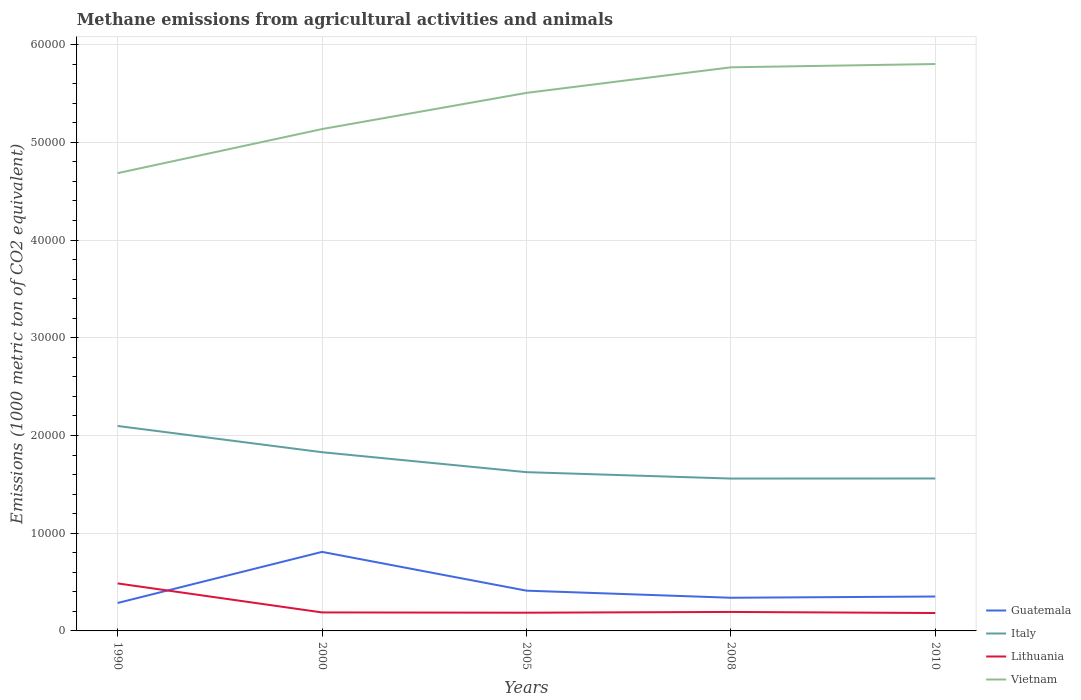Does the line corresponding to Italy intersect with the line corresponding to Guatemala?
Offer a very short reply. No. Across all years, what is the maximum amount of methane emitted in Guatemala?
Make the answer very short. 2860.2. What is the total amount of methane emitted in Lithuania in the graph?
Your answer should be compact. 2997.3. What is the difference between the highest and the second highest amount of methane emitted in Vietnam?
Your response must be concise. 1.12e+04. What is the difference between the highest and the lowest amount of methane emitted in Vietnam?
Make the answer very short. 3. Is the amount of methane emitted in Lithuania strictly greater than the amount of methane emitted in Guatemala over the years?
Your response must be concise. No. Are the values on the major ticks of Y-axis written in scientific E-notation?
Provide a short and direct response. No. Does the graph contain grids?
Keep it short and to the point. Yes. Where does the legend appear in the graph?
Offer a very short reply. Bottom right. What is the title of the graph?
Make the answer very short. Methane emissions from agricultural activities and animals. What is the label or title of the Y-axis?
Your response must be concise. Emissions (1000 metric ton of CO2 equivalent). What is the Emissions (1000 metric ton of CO2 equivalent) in Guatemala in 1990?
Your answer should be very brief. 2860.2. What is the Emissions (1000 metric ton of CO2 equivalent) in Italy in 1990?
Your response must be concise. 2.10e+04. What is the Emissions (1000 metric ton of CO2 equivalent) in Lithuania in 1990?
Keep it short and to the point. 4861.3. What is the Emissions (1000 metric ton of CO2 equivalent) in Vietnam in 1990?
Make the answer very short. 4.68e+04. What is the Emissions (1000 metric ton of CO2 equivalent) in Guatemala in 2000?
Offer a terse response. 8089.2. What is the Emissions (1000 metric ton of CO2 equivalent) of Italy in 2000?
Your answer should be compact. 1.83e+04. What is the Emissions (1000 metric ton of CO2 equivalent) in Lithuania in 2000?
Give a very brief answer. 1892.9. What is the Emissions (1000 metric ton of CO2 equivalent) of Vietnam in 2000?
Offer a very short reply. 5.14e+04. What is the Emissions (1000 metric ton of CO2 equivalent) in Guatemala in 2005?
Your response must be concise. 4120.8. What is the Emissions (1000 metric ton of CO2 equivalent) in Italy in 2005?
Offer a terse response. 1.62e+04. What is the Emissions (1000 metric ton of CO2 equivalent) in Lithuania in 2005?
Provide a short and direct response. 1864. What is the Emissions (1000 metric ton of CO2 equivalent) of Vietnam in 2005?
Make the answer very short. 5.51e+04. What is the Emissions (1000 metric ton of CO2 equivalent) of Guatemala in 2008?
Ensure brevity in your answer.  3394.9. What is the Emissions (1000 metric ton of CO2 equivalent) in Italy in 2008?
Offer a very short reply. 1.56e+04. What is the Emissions (1000 metric ton of CO2 equivalent) in Lithuania in 2008?
Give a very brief answer. 1942.5. What is the Emissions (1000 metric ton of CO2 equivalent) in Vietnam in 2008?
Your response must be concise. 5.77e+04. What is the Emissions (1000 metric ton of CO2 equivalent) in Guatemala in 2010?
Offer a terse response. 3521.2. What is the Emissions (1000 metric ton of CO2 equivalent) in Italy in 2010?
Ensure brevity in your answer.  1.56e+04. What is the Emissions (1000 metric ton of CO2 equivalent) in Lithuania in 2010?
Your answer should be compact. 1832.4. What is the Emissions (1000 metric ton of CO2 equivalent) of Vietnam in 2010?
Make the answer very short. 5.80e+04. Across all years, what is the maximum Emissions (1000 metric ton of CO2 equivalent) in Guatemala?
Your answer should be compact. 8089.2. Across all years, what is the maximum Emissions (1000 metric ton of CO2 equivalent) of Italy?
Provide a short and direct response. 2.10e+04. Across all years, what is the maximum Emissions (1000 metric ton of CO2 equivalent) in Lithuania?
Offer a very short reply. 4861.3. Across all years, what is the maximum Emissions (1000 metric ton of CO2 equivalent) in Vietnam?
Your answer should be compact. 5.80e+04. Across all years, what is the minimum Emissions (1000 metric ton of CO2 equivalent) of Guatemala?
Provide a short and direct response. 2860.2. Across all years, what is the minimum Emissions (1000 metric ton of CO2 equivalent) of Italy?
Provide a short and direct response. 1.56e+04. Across all years, what is the minimum Emissions (1000 metric ton of CO2 equivalent) in Lithuania?
Offer a terse response. 1832.4. Across all years, what is the minimum Emissions (1000 metric ton of CO2 equivalent) in Vietnam?
Your response must be concise. 4.68e+04. What is the total Emissions (1000 metric ton of CO2 equivalent) in Guatemala in the graph?
Your response must be concise. 2.20e+04. What is the total Emissions (1000 metric ton of CO2 equivalent) of Italy in the graph?
Offer a terse response. 8.67e+04. What is the total Emissions (1000 metric ton of CO2 equivalent) of Lithuania in the graph?
Offer a very short reply. 1.24e+04. What is the total Emissions (1000 metric ton of CO2 equivalent) of Vietnam in the graph?
Ensure brevity in your answer.  2.69e+05. What is the difference between the Emissions (1000 metric ton of CO2 equivalent) of Guatemala in 1990 and that in 2000?
Keep it short and to the point. -5229. What is the difference between the Emissions (1000 metric ton of CO2 equivalent) of Italy in 1990 and that in 2000?
Your answer should be very brief. 2687.3. What is the difference between the Emissions (1000 metric ton of CO2 equivalent) in Lithuania in 1990 and that in 2000?
Offer a very short reply. 2968.4. What is the difference between the Emissions (1000 metric ton of CO2 equivalent) of Vietnam in 1990 and that in 2000?
Your response must be concise. -4511. What is the difference between the Emissions (1000 metric ton of CO2 equivalent) in Guatemala in 1990 and that in 2005?
Offer a terse response. -1260.6. What is the difference between the Emissions (1000 metric ton of CO2 equivalent) of Italy in 1990 and that in 2005?
Keep it short and to the point. 4727.8. What is the difference between the Emissions (1000 metric ton of CO2 equivalent) in Lithuania in 1990 and that in 2005?
Keep it short and to the point. 2997.3. What is the difference between the Emissions (1000 metric ton of CO2 equivalent) of Vietnam in 1990 and that in 2005?
Make the answer very short. -8213.9. What is the difference between the Emissions (1000 metric ton of CO2 equivalent) of Guatemala in 1990 and that in 2008?
Give a very brief answer. -534.7. What is the difference between the Emissions (1000 metric ton of CO2 equivalent) in Italy in 1990 and that in 2008?
Provide a succinct answer. 5383.9. What is the difference between the Emissions (1000 metric ton of CO2 equivalent) in Lithuania in 1990 and that in 2008?
Make the answer very short. 2918.8. What is the difference between the Emissions (1000 metric ton of CO2 equivalent) in Vietnam in 1990 and that in 2008?
Make the answer very short. -1.08e+04. What is the difference between the Emissions (1000 metric ton of CO2 equivalent) in Guatemala in 1990 and that in 2010?
Ensure brevity in your answer.  -661. What is the difference between the Emissions (1000 metric ton of CO2 equivalent) of Italy in 1990 and that in 2010?
Make the answer very short. 5375.7. What is the difference between the Emissions (1000 metric ton of CO2 equivalent) in Lithuania in 1990 and that in 2010?
Your response must be concise. 3028.9. What is the difference between the Emissions (1000 metric ton of CO2 equivalent) of Vietnam in 1990 and that in 2010?
Ensure brevity in your answer.  -1.12e+04. What is the difference between the Emissions (1000 metric ton of CO2 equivalent) of Guatemala in 2000 and that in 2005?
Make the answer very short. 3968.4. What is the difference between the Emissions (1000 metric ton of CO2 equivalent) of Italy in 2000 and that in 2005?
Offer a very short reply. 2040.5. What is the difference between the Emissions (1000 metric ton of CO2 equivalent) in Lithuania in 2000 and that in 2005?
Provide a short and direct response. 28.9. What is the difference between the Emissions (1000 metric ton of CO2 equivalent) in Vietnam in 2000 and that in 2005?
Offer a very short reply. -3702.9. What is the difference between the Emissions (1000 metric ton of CO2 equivalent) of Guatemala in 2000 and that in 2008?
Your answer should be very brief. 4694.3. What is the difference between the Emissions (1000 metric ton of CO2 equivalent) of Italy in 2000 and that in 2008?
Provide a succinct answer. 2696.6. What is the difference between the Emissions (1000 metric ton of CO2 equivalent) in Lithuania in 2000 and that in 2008?
Keep it short and to the point. -49.6. What is the difference between the Emissions (1000 metric ton of CO2 equivalent) in Vietnam in 2000 and that in 2008?
Your answer should be very brief. -6319.4. What is the difference between the Emissions (1000 metric ton of CO2 equivalent) of Guatemala in 2000 and that in 2010?
Your answer should be very brief. 4568. What is the difference between the Emissions (1000 metric ton of CO2 equivalent) in Italy in 2000 and that in 2010?
Provide a succinct answer. 2688.4. What is the difference between the Emissions (1000 metric ton of CO2 equivalent) in Lithuania in 2000 and that in 2010?
Provide a short and direct response. 60.5. What is the difference between the Emissions (1000 metric ton of CO2 equivalent) of Vietnam in 2000 and that in 2010?
Offer a terse response. -6656.2. What is the difference between the Emissions (1000 metric ton of CO2 equivalent) of Guatemala in 2005 and that in 2008?
Provide a short and direct response. 725.9. What is the difference between the Emissions (1000 metric ton of CO2 equivalent) in Italy in 2005 and that in 2008?
Ensure brevity in your answer.  656.1. What is the difference between the Emissions (1000 metric ton of CO2 equivalent) in Lithuania in 2005 and that in 2008?
Your answer should be compact. -78.5. What is the difference between the Emissions (1000 metric ton of CO2 equivalent) of Vietnam in 2005 and that in 2008?
Provide a succinct answer. -2616.5. What is the difference between the Emissions (1000 metric ton of CO2 equivalent) in Guatemala in 2005 and that in 2010?
Provide a succinct answer. 599.6. What is the difference between the Emissions (1000 metric ton of CO2 equivalent) in Italy in 2005 and that in 2010?
Ensure brevity in your answer.  647.9. What is the difference between the Emissions (1000 metric ton of CO2 equivalent) of Lithuania in 2005 and that in 2010?
Ensure brevity in your answer.  31.6. What is the difference between the Emissions (1000 metric ton of CO2 equivalent) in Vietnam in 2005 and that in 2010?
Make the answer very short. -2953.3. What is the difference between the Emissions (1000 metric ton of CO2 equivalent) in Guatemala in 2008 and that in 2010?
Your answer should be compact. -126.3. What is the difference between the Emissions (1000 metric ton of CO2 equivalent) of Italy in 2008 and that in 2010?
Give a very brief answer. -8.2. What is the difference between the Emissions (1000 metric ton of CO2 equivalent) of Lithuania in 2008 and that in 2010?
Keep it short and to the point. 110.1. What is the difference between the Emissions (1000 metric ton of CO2 equivalent) in Vietnam in 2008 and that in 2010?
Keep it short and to the point. -336.8. What is the difference between the Emissions (1000 metric ton of CO2 equivalent) of Guatemala in 1990 and the Emissions (1000 metric ton of CO2 equivalent) of Italy in 2000?
Your answer should be very brief. -1.54e+04. What is the difference between the Emissions (1000 metric ton of CO2 equivalent) of Guatemala in 1990 and the Emissions (1000 metric ton of CO2 equivalent) of Lithuania in 2000?
Your response must be concise. 967.3. What is the difference between the Emissions (1000 metric ton of CO2 equivalent) in Guatemala in 1990 and the Emissions (1000 metric ton of CO2 equivalent) in Vietnam in 2000?
Make the answer very short. -4.85e+04. What is the difference between the Emissions (1000 metric ton of CO2 equivalent) of Italy in 1990 and the Emissions (1000 metric ton of CO2 equivalent) of Lithuania in 2000?
Provide a succinct answer. 1.91e+04. What is the difference between the Emissions (1000 metric ton of CO2 equivalent) of Italy in 1990 and the Emissions (1000 metric ton of CO2 equivalent) of Vietnam in 2000?
Offer a very short reply. -3.04e+04. What is the difference between the Emissions (1000 metric ton of CO2 equivalent) in Lithuania in 1990 and the Emissions (1000 metric ton of CO2 equivalent) in Vietnam in 2000?
Keep it short and to the point. -4.65e+04. What is the difference between the Emissions (1000 metric ton of CO2 equivalent) of Guatemala in 1990 and the Emissions (1000 metric ton of CO2 equivalent) of Italy in 2005?
Your answer should be compact. -1.34e+04. What is the difference between the Emissions (1000 metric ton of CO2 equivalent) of Guatemala in 1990 and the Emissions (1000 metric ton of CO2 equivalent) of Lithuania in 2005?
Keep it short and to the point. 996.2. What is the difference between the Emissions (1000 metric ton of CO2 equivalent) in Guatemala in 1990 and the Emissions (1000 metric ton of CO2 equivalent) in Vietnam in 2005?
Your answer should be compact. -5.22e+04. What is the difference between the Emissions (1000 metric ton of CO2 equivalent) in Italy in 1990 and the Emissions (1000 metric ton of CO2 equivalent) in Lithuania in 2005?
Offer a terse response. 1.91e+04. What is the difference between the Emissions (1000 metric ton of CO2 equivalent) of Italy in 1990 and the Emissions (1000 metric ton of CO2 equivalent) of Vietnam in 2005?
Your answer should be compact. -3.41e+04. What is the difference between the Emissions (1000 metric ton of CO2 equivalent) in Lithuania in 1990 and the Emissions (1000 metric ton of CO2 equivalent) in Vietnam in 2005?
Give a very brief answer. -5.02e+04. What is the difference between the Emissions (1000 metric ton of CO2 equivalent) in Guatemala in 1990 and the Emissions (1000 metric ton of CO2 equivalent) in Italy in 2008?
Make the answer very short. -1.27e+04. What is the difference between the Emissions (1000 metric ton of CO2 equivalent) of Guatemala in 1990 and the Emissions (1000 metric ton of CO2 equivalent) of Lithuania in 2008?
Your answer should be very brief. 917.7. What is the difference between the Emissions (1000 metric ton of CO2 equivalent) in Guatemala in 1990 and the Emissions (1000 metric ton of CO2 equivalent) in Vietnam in 2008?
Offer a terse response. -5.48e+04. What is the difference between the Emissions (1000 metric ton of CO2 equivalent) in Italy in 1990 and the Emissions (1000 metric ton of CO2 equivalent) in Lithuania in 2008?
Ensure brevity in your answer.  1.90e+04. What is the difference between the Emissions (1000 metric ton of CO2 equivalent) of Italy in 1990 and the Emissions (1000 metric ton of CO2 equivalent) of Vietnam in 2008?
Your response must be concise. -3.67e+04. What is the difference between the Emissions (1000 metric ton of CO2 equivalent) in Lithuania in 1990 and the Emissions (1000 metric ton of CO2 equivalent) in Vietnam in 2008?
Your answer should be compact. -5.28e+04. What is the difference between the Emissions (1000 metric ton of CO2 equivalent) in Guatemala in 1990 and the Emissions (1000 metric ton of CO2 equivalent) in Italy in 2010?
Your response must be concise. -1.27e+04. What is the difference between the Emissions (1000 metric ton of CO2 equivalent) in Guatemala in 1990 and the Emissions (1000 metric ton of CO2 equivalent) in Lithuania in 2010?
Your answer should be compact. 1027.8. What is the difference between the Emissions (1000 metric ton of CO2 equivalent) in Guatemala in 1990 and the Emissions (1000 metric ton of CO2 equivalent) in Vietnam in 2010?
Provide a succinct answer. -5.52e+04. What is the difference between the Emissions (1000 metric ton of CO2 equivalent) in Italy in 1990 and the Emissions (1000 metric ton of CO2 equivalent) in Lithuania in 2010?
Give a very brief answer. 1.91e+04. What is the difference between the Emissions (1000 metric ton of CO2 equivalent) in Italy in 1990 and the Emissions (1000 metric ton of CO2 equivalent) in Vietnam in 2010?
Keep it short and to the point. -3.70e+04. What is the difference between the Emissions (1000 metric ton of CO2 equivalent) of Lithuania in 1990 and the Emissions (1000 metric ton of CO2 equivalent) of Vietnam in 2010?
Offer a very short reply. -5.32e+04. What is the difference between the Emissions (1000 metric ton of CO2 equivalent) of Guatemala in 2000 and the Emissions (1000 metric ton of CO2 equivalent) of Italy in 2005?
Your answer should be compact. -8158.4. What is the difference between the Emissions (1000 metric ton of CO2 equivalent) of Guatemala in 2000 and the Emissions (1000 metric ton of CO2 equivalent) of Lithuania in 2005?
Your answer should be compact. 6225.2. What is the difference between the Emissions (1000 metric ton of CO2 equivalent) in Guatemala in 2000 and the Emissions (1000 metric ton of CO2 equivalent) in Vietnam in 2005?
Make the answer very short. -4.70e+04. What is the difference between the Emissions (1000 metric ton of CO2 equivalent) in Italy in 2000 and the Emissions (1000 metric ton of CO2 equivalent) in Lithuania in 2005?
Offer a terse response. 1.64e+04. What is the difference between the Emissions (1000 metric ton of CO2 equivalent) in Italy in 2000 and the Emissions (1000 metric ton of CO2 equivalent) in Vietnam in 2005?
Offer a very short reply. -3.68e+04. What is the difference between the Emissions (1000 metric ton of CO2 equivalent) of Lithuania in 2000 and the Emissions (1000 metric ton of CO2 equivalent) of Vietnam in 2005?
Keep it short and to the point. -5.32e+04. What is the difference between the Emissions (1000 metric ton of CO2 equivalent) of Guatemala in 2000 and the Emissions (1000 metric ton of CO2 equivalent) of Italy in 2008?
Make the answer very short. -7502.3. What is the difference between the Emissions (1000 metric ton of CO2 equivalent) in Guatemala in 2000 and the Emissions (1000 metric ton of CO2 equivalent) in Lithuania in 2008?
Your answer should be very brief. 6146.7. What is the difference between the Emissions (1000 metric ton of CO2 equivalent) of Guatemala in 2000 and the Emissions (1000 metric ton of CO2 equivalent) of Vietnam in 2008?
Provide a short and direct response. -4.96e+04. What is the difference between the Emissions (1000 metric ton of CO2 equivalent) of Italy in 2000 and the Emissions (1000 metric ton of CO2 equivalent) of Lithuania in 2008?
Offer a terse response. 1.63e+04. What is the difference between the Emissions (1000 metric ton of CO2 equivalent) in Italy in 2000 and the Emissions (1000 metric ton of CO2 equivalent) in Vietnam in 2008?
Your answer should be compact. -3.94e+04. What is the difference between the Emissions (1000 metric ton of CO2 equivalent) in Lithuania in 2000 and the Emissions (1000 metric ton of CO2 equivalent) in Vietnam in 2008?
Provide a succinct answer. -5.58e+04. What is the difference between the Emissions (1000 metric ton of CO2 equivalent) in Guatemala in 2000 and the Emissions (1000 metric ton of CO2 equivalent) in Italy in 2010?
Provide a succinct answer. -7510.5. What is the difference between the Emissions (1000 metric ton of CO2 equivalent) of Guatemala in 2000 and the Emissions (1000 metric ton of CO2 equivalent) of Lithuania in 2010?
Keep it short and to the point. 6256.8. What is the difference between the Emissions (1000 metric ton of CO2 equivalent) of Guatemala in 2000 and the Emissions (1000 metric ton of CO2 equivalent) of Vietnam in 2010?
Give a very brief answer. -4.99e+04. What is the difference between the Emissions (1000 metric ton of CO2 equivalent) of Italy in 2000 and the Emissions (1000 metric ton of CO2 equivalent) of Lithuania in 2010?
Make the answer very short. 1.65e+04. What is the difference between the Emissions (1000 metric ton of CO2 equivalent) in Italy in 2000 and the Emissions (1000 metric ton of CO2 equivalent) in Vietnam in 2010?
Provide a succinct answer. -3.97e+04. What is the difference between the Emissions (1000 metric ton of CO2 equivalent) in Lithuania in 2000 and the Emissions (1000 metric ton of CO2 equivalent) in Vietnam in 2010?
Make the answer very short. -5.61e+04. What is the difference between the Emissions (1000 metric ton of CO2 equivalent) in Guatemala in 2005 and the Emissions (1000 metric ton of CO2 equivalent) in Italy in 2008?
Offer a terse response. -1.15e+04. What is the difference between the Emissions (1000 metric ton of CO2 equivalent) of Guatemala in 2005 and the Emissions (1000 metric ton of CO2 equivalent) of Lithuania in 2008?
Your answer should be very brief. 2178.3. What is the difference between the Emissions (1000 metric ton of CO2 equivalent) of Guatemala in 2005 and the Emissions (1000 metric ton of CO2 equivalent) of Vietnam in 2008?
Keep it short and to the point. -5.36e+04. What is the difference between the Emissions (1000 metric ton of CO2 equivalent) of Italy in 2005 and the Emissions (1000 metric ton of CO2 equivalent) of Lithuania in 2008?
Keep it short and to the point. 1.43e+04. What is the difference between the Emissions (1000 metric ton of CO2 equivalent) of Italy in 2005 and the Emissions (1000 metric ton of CO2 equivalent) of Vietnam in 2008?
Offer a very short reply. -4.14e+04. What is the difference between the Emissions (1000 metric ton of CO2 equivalent) in Lithuania in 2005 and the Emissions (1000 metric ton of CO2 equivalent) in Vietnam in 2008?
Your response must be concise. -5.58e+04. What is the difference between the Emissions (1000 metric ton of CO2 equivalent) in Guatemala in 2005 and the Emissions (1000 metric ton of CO2 equivalent) in Italy in 2010?
Offer a very short reply. -1.15e+04. What is the difference between the Emissions (1000 metric ton of CO2 equivalent) of Guatemala in 2005 and the Emissions (1000 metric ton of CO2 equivalent) of Lithuania in 2010?
Make the answer very short. 2288.4. What is the difference between the Emissions (1000 metric ton of CO2 equivalent) of Guatemala in 2005 and the Emissions (1000 metric ton of CO2 equivalent) of Vietnam in 2010?
Provide a short and direct response. -5.39e+04. What is the difference between the Emissions (1000 metric ton of CO2 equivalent) of Italy in 2005 and the Emissions (1000 metric ton of CO2 equivalent) of Lithuania in 2010?
Keep it short and to the point. 1.44e+04. What is the difference between the Emissions (1000 metric ton of CO2 equivalent) of Italy in 2005 and the Emissions (1000 metric ton of CO2 equivalent) of Vietnam in 2010?
Ensure brevity in your answer.  -4.18e+04. What is the difference between the Emissions (1000 metric ton of CO2 equivalent) in Lithuania in 2005 and the Emissions (1000 metric ton of CO2 equivalent) in Vietnam in 2010?
Offer a very short reply. -5.62e+04. What is the difference between the Emissions (1000 metric ton of CO2 equivalent) of Guatemala in 2008 and the Emissions (1000 metric ton of CO2 equivalent) of Italy in 2010?
Provide a short and direct response. -1.22e+04. What is the difference between the Emissions (1000 metric ton of CO2 equivalent) in Guatemala in 2008 and the Emissions (1000 metric ton of CO2 equivalent) in Lithuania in 2010?
Ensure brevity in your answer.  1562.5. What is the difference between the Emissions (1000 metric ton of CO2 equivalent) in Guatemala in 2008 and the Emissions (1000 metric ton of CO2 equivalent) in Vietnam in 2010?
Keep it short and to the point. -5.46e+04. What is the difference between the Emissions (1000 metric ton of CO2 equivalent) in Italy in 2008 and the Emissions (1000 metric ton of CO2 equivalent) in Lithuania in 2010?
Provide a short and direct response. 1.38e+04. What is the difference between the Emissions (1000 metric ton of CO2 equivalent) in Italy in 2008 and the Emissions (1000 metric ton of CO2 equivalent) in Vietnam in 2010?
Your answer should be very brief. -4.24e+04. What is the difference between the Emissions (1000 metric ton of CO2 equivalent) of Lithuania in 2008 and the Emissions (1000 metric ton of CO2 equivalent) of Vietnam in 2010?
Provide a short and direct response. -5.61e+04. What is the average Emissions (1000 metric ton of CO2 equivalent) of Guatemala per year?
Your response must be concise. 4397.26. What is the average Emissions (1000 metric ton of CO2 equivalent) in Italy per year?
Make the answer very short. 1.73e+04. What is the average Emissions (1000 metric ton of CO2 equivalent) in Lithuania per year?
Give a very brief answer. 2478.62. What is the average Emissions (1000 metric ton of CO2 equivalent) of Vietnam per year?
Offer a terse response. 5.38e+04. In the year 1990, what is the difference between the Emissions (1000 metric ton of CO2 equivalent) in Guatemala and Emissions (1000 metric ton of CO2 equivalent) in Italy?
Ensure brevity in your answer.  -1.81e+04. In the year 1990, what is the difference between the Emissions (1000 metric ton of CO2 equivalent) of Guatemala and Emissions (1000 metric ton of CO2 equivalent) of Lithuania?
Provide a succinct answer. -2001.1. In the year 1990, what is the difference between the Emissions (1000 metric ton of CO2 equivalent) of Guatemala and Emissions (1000 metric ton of CO2 equivalent) of Vietnam?
Provide a short and direct response. -4.40e+04. In the year 1990, what is the difference between the Emissions (1000 metric ton of CO2 equivalent) of Italy and Emissions (1000 metric ton of CO2 equivalent) of Lithuania?
Provide a short and direct response. 1.61e+04. In the year 1990, what is the difference between the Emissions (1000 metric ton of CO2 equivalent) in Italy and Emissions (1000 metric ton of CO2 equivalent) in Vietnam?
Keep it short and to the point. -2.59e+04. In the year 1990, what is the difference between the Emissions (1000 metric ton of CO2 equivalent) in Lithuania and Emissions (1000 metric ton of CO2 equivalent) in Vietnam?
Make the answer very short. -4.20e+04. In the year 2000, what is the difference between the Emissions (1000 metric ton of CO2 equivalent) of Guatemala and Emissions (1000 metric ton of CO2 equivalent) of Italy?
Your answer should be very brief. -1.02e+04. In the year 2000, what is the difference between the Emissions (1000 metric ton of CO2 equivalent) in Guatemala and Emissions (1000 metric ton of CO2 equivalent) in Lithuania?
Make the answer very short. 6196.3. In the year 2000, what is the difference between the Emissions (1000 metric ton of CO2 equivalent) in Guatemala and Emissions (1000 metric ton of CO2 equivalent) in Vietnam?
Your answer should be very brief. -4.33e+04. In the year 2000, what is the difference between the Emissions (1000 metric ton of CO2 equivalent) in Italy and Emissions (1000 metric ton of CO2 equivalent) in Lithuania?
Your response must be concise. 1.64e+04. In the year 2000, what is the difference between the Emissions (1000 metric ton of CO2 equivalent) in Italy and Emissions (1000 metric ton of CO2 equivalent) in Vietnam?
Your answer should be very brief. -3.31e+04. In the year 2000, what is the difference between the Emissions (1000 metric ton of CO2 equivalent) in Lithuania and Emissions (1000 metric ton of CO2 equivalent) in Vietnam?
Offer a very short reply. -4.95e+04. In the year 2005, what is the difference between the Emissions (1000 metric ton of CO2 equivalent) in Guatemala and Emissions (1000 metric ton of CO2 equivalent) in Italy?
Provide a succinct answer. -1.21e+04. In the year 2005, what is the difference between the Emissions (1000 metric ton of CO2 equivalent) of Guatemala and Emissions (1000 metric ton of CO2 equivalent) of Lithuania?
Provide a succinct answer. 2256.8. In the year 2005, what is the difference between the Emissions (1000 metric ton of CO2 equivalent) of Guatemala and Emissions (1000 metric ton of CO2 equivalent) of Vietnam?
Give a very brief answer. -5.09e+04. In the year 2005, what is the difference between the Emissions (1000 metric ton of CO2 equivalent) in Italy and Emissions (1000 metric ton of CO2 equivalent) in Lithuania?
Ensure brevity in your answer.  1.44e+04. In the year 2005, what is the difference between the Emissions (1000 metric ton of CO2 equivalent) in Italy and Emissions (1000 metric ton of CO2 equivalent) in Vietnam?
Provide a short and direct response. -3.88e+04. In the year 2005, what is the difference between the Emissions (1000 metric ton of CO2 equivalent) in Lithuania and Emissions (1000 metric ton of CO2 equivalent) in Vietnam?
Your answer should be very brief. -5.32e+04. In the year 2008, what is the difference between the Emissions (1000 metric ton of CO2 equivalent) of Guatemala and Emissions (1000 metric ton of CO2 equivalent) of Italy?
Provide a succinct answer. -1.22e+04. In the year 2008, what is the difference between the Emissions (1000 metric ton of CO2 equivalent) of Guatemala and Emissions (1000 metric ton of CO2 equivalent) of Lithuania?
Provide a short and direct response. 1452.4. In the year 2008, what is the difference between the Emissions (1000 metric ton of CO2 equivalent) of Guatemala and Emissions (1000 metric ton of CO2 equivalent) of Vietnam?
Make the answer very short. -5.43e+04. In the year 2008, what is the difference between the Emissions (1000 metric ton of CO2 equivalent) of Italy and Emissions (1000 metric ton of CO2 equivalent) of Lithuania?
Provide a short and direct response. 1.36e+04. In the year 2008, what is the difference between the Emissions (1000 metric ton of CO2 equivalent) of Italy and Emissions (1000 metric ton of CO2 equivalent) of Vietnam?
Offer a terse response. -4.21e+04. In the year 2008, what is the difference between the Emissions (1000 metric ton of CO2 equivalent) in Lithuania and Emissions (1000 metric ton of CO2 equivalent) in Vietnam?
Your answer should be compact. -5.57e+04. In the year 2010, what is the difference between the Emissions (1000 metric ton of CO2 equivalent) of Guatemala and Emissions (1000 metric ton of CO2 equivalent) of Italy?
Keep it short and to the point. -1.21e+04. In the year 2010, what is the difference between the Emissions (1000 metric ton of CO2 equivalent) in Guatemala and Emissions (1000 metric ton of CO2 equivalent) in Lithuania?
Provide a succinct answer. 1688.8. In the year 2010, what is the difference between the Emissions (1000 metric ton of CO2 equivalent) in Guatemala and Emissions (1000 metric ton of CO2 equivalent) in Vietnam?
Offer a terse response. -5.45e+04. In the year 2010, what is the difference between the Emissions (1000 metric ton of CO2 equivalent) in Italy and Emissions (1000 metric ton of CO2 equivalent) in Lithuania?
Offer a very short reply. 1.38e+04. In the year 2010, what is the difference between the Emissions (1000 metric ton of CO2 equivalent) of Italy and Emissions (1000 metric ton of CO2 equivalent) of Vietnam?
Ensure brevity in your answer.  -4.24e+04. In the year 2010, what is the difference between the Emissions (1000 metric ton of CO2 equivalent) in Lithuania and Emissions (1000 metric ton of CO2 equivalent) in Vietnam?
Your response must be concise. -5.62e+04. What is the ratio of the Emissions (1000 metric ton of CO2 equivalent) of Guatemala in 1990 to that in 2000?
Give a very brief answer. 0.35. What is the ratio of the Emissions (1000 metric ton of CO2 equivalent) of Italy in 1990 to that in 2000?
Your answer should be compact. 1.15. What is the ratio of the Emissions (1000 metric ton of CO2 equivalent) of Lithuania in 1990 to that in 2000?
Provide a succinct answer. 2.57. What is the ratio of the Emissions (1000 metric ton of CO2 equivalent) in Vietnam in 1990 to that in 2000?
Offer a very short reply. 0.91. What is the ratio of the Emissions (1000 metric ton of CO2 equivalent) of Guatemala in 1990 to that in 2005?
Your answer should be compact. 0.69. What is the ratio of the Emissions (1000 metric ton of CO2 equivalent) of Italy in 1990 to that in 2005?
Provide a short and direct response. 1.29. What is the ratio of the Emissions (1000 metric ton of CO2 equivalent) in Lithuania in 1990 to that in 2005?
Make the answer very short. 2.61. What is the ratio of the Emissions (1000 metric ton of CO2 equivalent) in Vietnam in 1990 to that in 2005?
Make the answer very short. 0.85. What is the ratio of the Emissions (1000 metric ton of CO2 equivalent) of Guatemala in 1990 to that in 2008?
Offer a terse response. 0.84. What is the ratio of the Emissions (1000 metric ton of CO2 equivalent) of Italy in 1990 to that in 2008?
Keep it short and to the point. 1.35. What is the ratio of the Emissions (1000 metric ton of CO2 equivalent) of Lithuania in 1990 to that in 2008?
Give a very brief answer. 2.5. What is the ratio of the Emissions (1000 metric ton of CO2 equivalent) in Vietnam in 1990 to that in 2008?
Provide a succinct answer. 0.81. What is the ratio of the Emissions (1000 metric ton of CO2 equivalent) in Guatemala in 1990 to that in 2010?
Offer a terse response. 0.81. What is the ratio of the Emissions (1000 metric ton of CO2 equivalent) in Italy in 1990 to that in 2010?
Give a very brief answer. 1.34. What is the ratio of the Emissions (1000 metric ton of CO2 equivalent) of Lithuania in 1990 to that in 2010?
Your response must be concise. 2.65. What is the ratio of the Emissions (1000 metric ton of CO2 equivalent) of Vietnam in 1990 to that in 2010?
Give a very brief answer. 0.81. What is the ratio of the Emissions (1000 metric ton of CO2 equivalent) of Guatemala in 2000 to that in 2005?
Offer a very short reply. 1.96. What is the ratio of the Emissions (1000 metric ton of CO2 equivalent) in Italy in 2000 to that in 2005?
Your answer should be compact. 1.13. What is the ratio of the Emissions (1000 metric ton of CO2 equivalent) of Lithuania in 2000 to that in 2005?
Make the answer very short. 1.02. What is the ratio of the Emissions (1000 metric ton of CO2 equivalent) in Vietnam in 2000 to that in 2005?
Offer a very short reply. 0.93. What is the ratio of the Emissions (1000 metric ton of CO2 equivalent) of Guatemala in 2000 to that in 2008?
Keep it short and to the point. 2.38. What is the ratio of the Emissions (1000 metric ton of CO2 equivalent) in Italy in 2000 to that in 2008?
Ensure brevity in your answer.  1.17. What is the ratio of the Emissions (1000 metric ton of CO2 equivalent) of Lithuania in 2000 to that in 2008?
Provide a short and direct response. 0.97. What is the ratio of the Emissions (1000 metric ton of CO2 equivalent) of Vietnam in 2000 to that in 2008?
Your answer should be compact. 0.89. What is the ratio of the Emissions (1000 metric ton of CO2 equivalent) in Guatemala in 2000 to that in 2010?
Your answer should be very brief. 2.3. What is the ratio of the Emissions (1000 metric ton of CO2 equivalent) in Italy in 2000 to that in 2010?
Your answer should be very brief. 1.17. What is the ratio of the Emissions (1000 metric ton of CO2 equivalent) of Lithuania in 2000 to that in 2010?
Keep it short and to the point. 1.03. What is the ratio of the Emissions (1000 metric ton of CO2 equivalent) of Vietnam in 2000 to that in 2010?
Your answer should be very brief. 0.89. What is the ratio of the Emissions (1000 metric ton of CO2 equivalent) in Guatemala in 2005 to that in 2008?
Provide a succinct answer. 1.21. What is the ratio of the Emissions (1000 metric ton of CO2 equivalent) in Italy in 2005 to that in 2008?
Offer a very short reply. 1.04. What is the ratio of the Emissions (1000 metric ton of CO2 equivalent) in Lithuania in 2005 to that in 2008?
Your answer should be very brief. 0.96. What is the ratio of the Emissions (1000 metric ton of CO2 equivalent) of Vietnam in 2005 to that in 2008?
Offer a very short reply. 0.95. What is the ratio of the Emissions (1000 metric ton of CO2 equivalent) of Guatemala in 2005 to that in 2010?
Your answer should be compact. 1.17. What is the ratio of the Emissions (1000 metric ton of CO2 equivalent) of Italy in 2005 to that in 2010?
Your answer should be compact. 1.04. What is the ratio of the Emissions (1000 metric ton of CO2 equivalent) of Lithuania in 2005 to that in 2010?
Provide a succinct answer. 1.02. What is the ratio of the Emissions (1000 metric ton of CO2 equivalent) in Vietnam in 2005 to that in 2010?
Provide a short and direct response. 0.95. What is the ratio of the Emissions (1000 metric ton of CO2 equivalent) of Guatemala in 2008 to that in 2010?
Provide a short and direct response. 0.96. What is the ratio of the Emissions (1000 metric ton of CO2 equivalent) in Italy in 2008 to that in 2010?
Your answer should be very brief. 1. What is the ratio of the Emissions (1000 metric ton of CO2 equivalent) of Lithuania in 2008 to that in 2010?
Your answer should be compact. 1.06. What is the difference between the highest and the second highest Emissions (1000 metric ton of CO2 equivalent) in Guatemala?
Your answer should be very brief. 3968.4. What is the difference between the highest and the second highest Emissions (1000 metric ton of CO2 equivalent) of Italy?
Your answer should be very brief. 2687.3. What is the difference between the highest and the second highest Emissions (1000 metric ton of CO2 equivalent) of Lithuania?
Your answer should be very brief. 2918.8. What is the difference between the highest and the second highest Emissions (1000 metric ton of CO2 equivalent) of Vietnam?
Your answer should be compact. 336.8. What is the difference between the highest and the lowest Emissions (1000 metric ton of CO2 equivalent) in Guatemala?
Ensure brevity in your answer.  5229. What is the difference between the highest and the lowest Emissions (1000 metric ton of CO2 equivalent) of Italy?
Provide a succinct answer. 5383.9. What is the difference between the highest and the lowest Emissions (1000 metric ton of CO2 equivalent) of Lithuania?
Provide a succinct answer. 3028.9. What is the difference between the highest and the lowest Emissions (1000 metric ton of CO2 equivalent) of Vietnam?
Make the answer very short. 1.12e+04. 